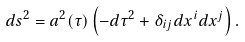Convert formula to latex. <formula><loc_0><loc_0><loc_500><loc_500>d s ^ { 2 } = a ^ { 2 } ( \tau ) \left ( - d \tau ^ { 2 } + \delta _ { i j } d x ^ { i } d x ^ { j } \right ) .</formula> 